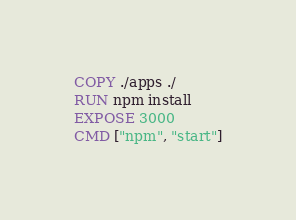<code> <loc_0><loc_0><loc_500><loc_500><_Dockerfile_>COPY ./apps ./
RUN npm install
EXPOSE 3000
CMD ["npm", "start"]</code> 